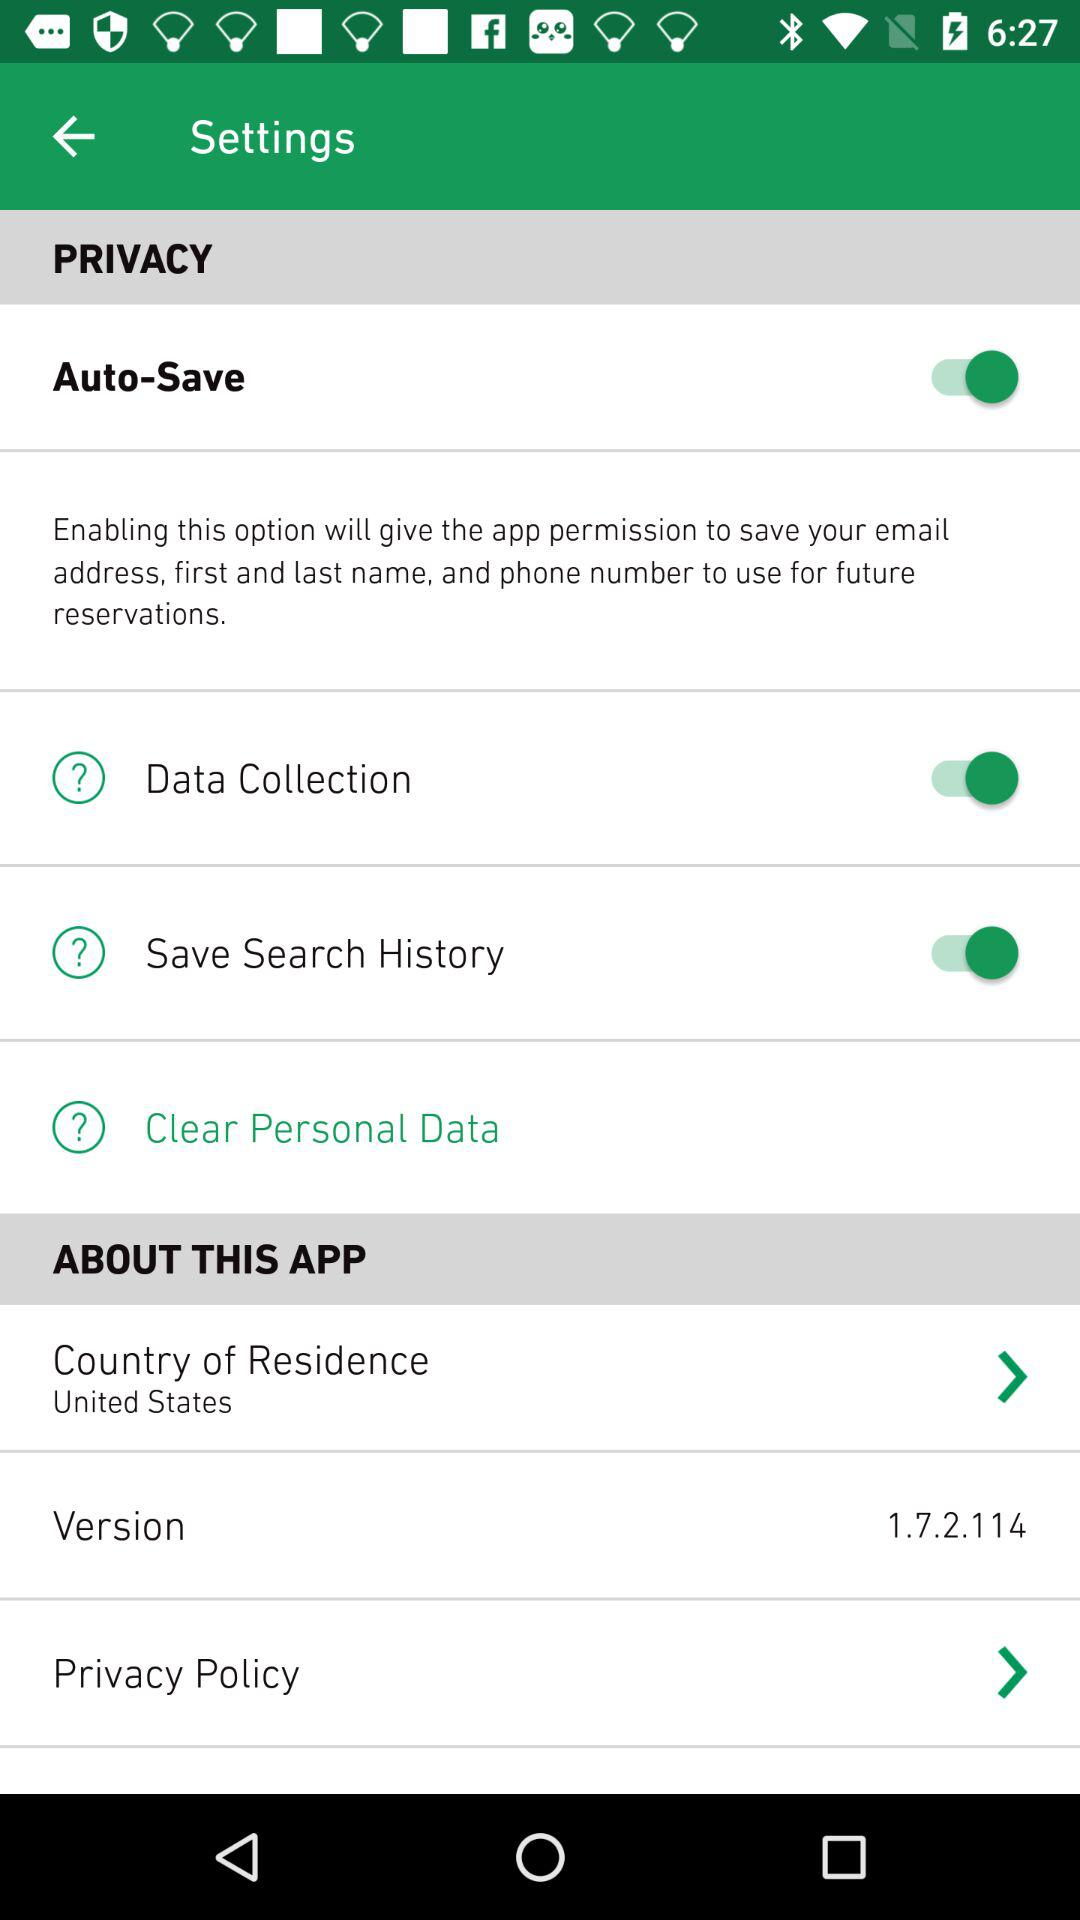How many items are in the Privacy section?
Answer the question using a single word or phrase. 4 